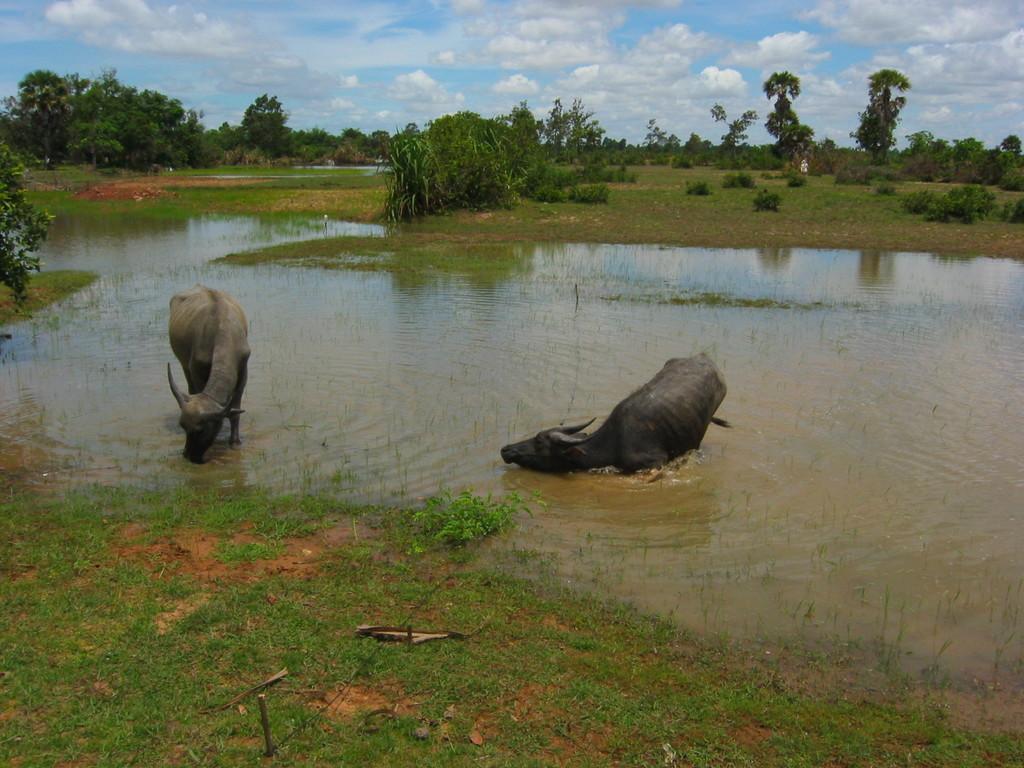Can you describe this image briefly? In this image there is a land, on that land there is water, in that water there are two buffaloes, in the background there are trees and the sky. 